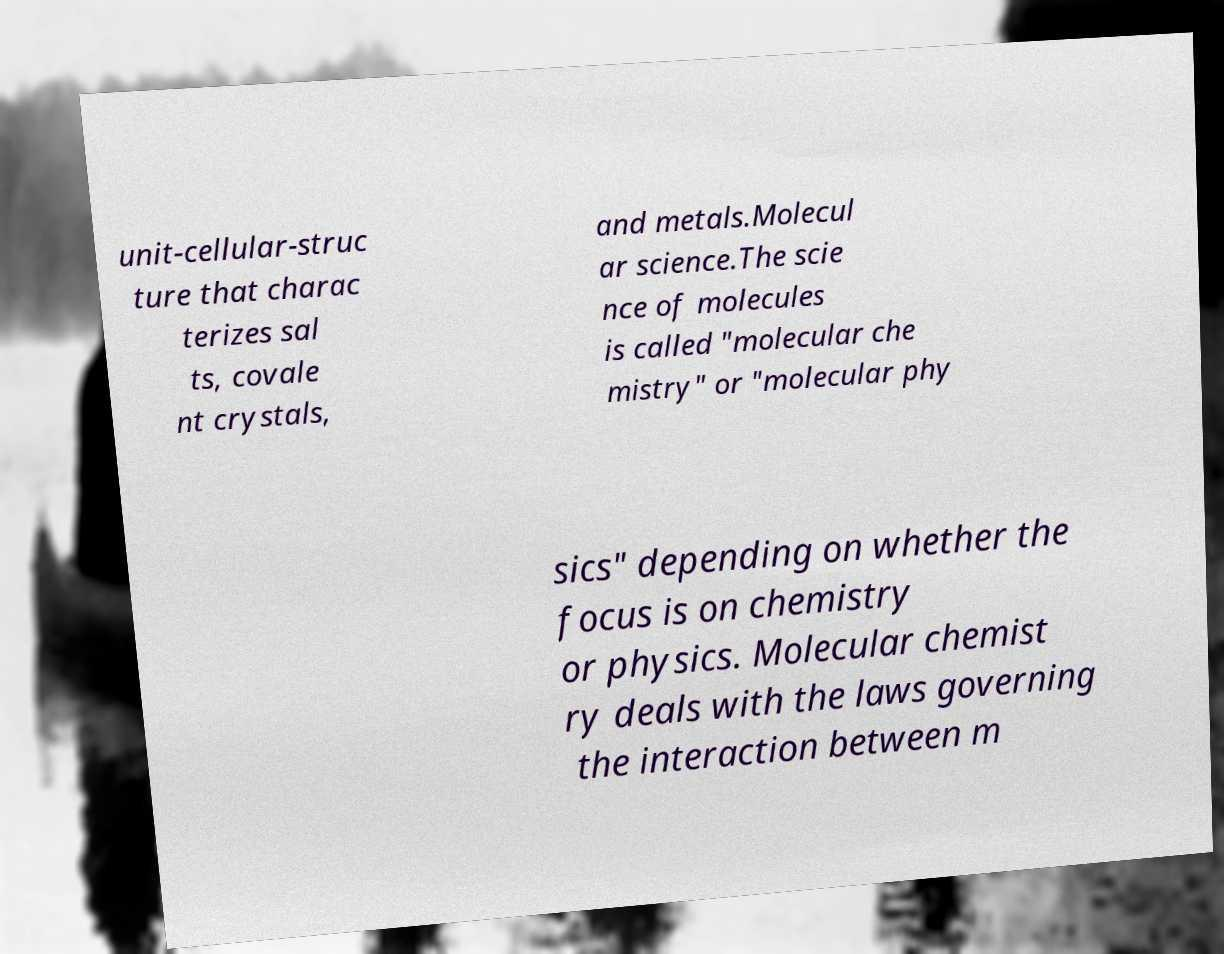Could you assist in decoding the text presented in this image and type it out clearly? unit-cellular-struc ture that charac terizes sal ts, covale nt crystals, and metals.Molecul ar science.The scie nce of molecules is called "molecular che mistry" or "molecular phy sics" depending on whether the focus is on chemistry or physics. Molecular chemist ry deals with the laws governing the interaction between m 